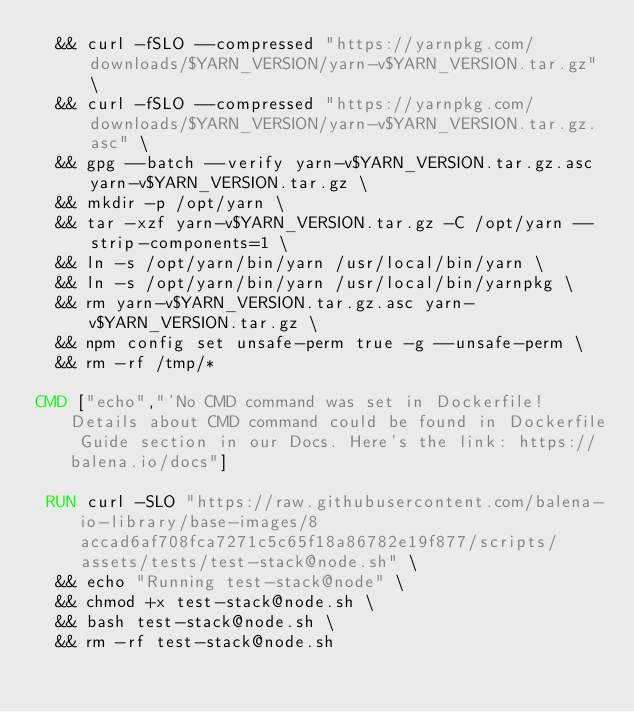<code> <loc_0><loc_0><loc_500><loc_500><_Dockerfile_>	&& curl -fSLO --compressed "https://yarnpkg.com/downloads/$YARN_VERSION/yarn-v$YARN_VERSION.tar.gz" \
	&& curl -fSLO --compressed "https://yarnpkg.com/downloads/$YARN_VERSION/yarn-v$YARN_VERSION.tar.gz.asc" \
	&& gpg --batch --verify yarn-v$YARN_VERSION.tar.gz.asc yarn-v$YARN_VERSION.tar.gz \
	&& mkdir -p /opt/yarn \
	&& tar -xzf yarn-v$YARN_VERSION.tar.gz -C /opt/yarn --strip-components=1 \
	&& ln -s /opt/yarn/bin/yarn /usr/local/bin/yarn \
	&& ln -s /opt/yarn/bin/yarn /usr/local/bin/yarnpkg \
	&& rm yarn-v$YARN_VERSION.tar.gz.asc yarn-v$YARN_VERSION.tar.gz \
	&& npm config set unsafe-perm true -g --unsafe-perm \
	&& rm -rf /tmp/*

CMD ["echo","'No CMD command was set in Dockerfile! Details about CMD command could be found in Dockerfile Guide section in our Docs. Here's the link: https://balena.io/docs"]

 RUN curl -SLO "https://raw.githubusercontent.com/balena-io-library/base-images/8accad6af708fca7271c5c65f18a86782e19f877/scripts/assets/tests/test-stack@node.sh" \
  && echo "Running test-stack@node" \
  && chmod +x test-stack@node.sh \
  && bash test-stack@node.sh \
  && rm -rf test-stack@node.sh 
</code> 